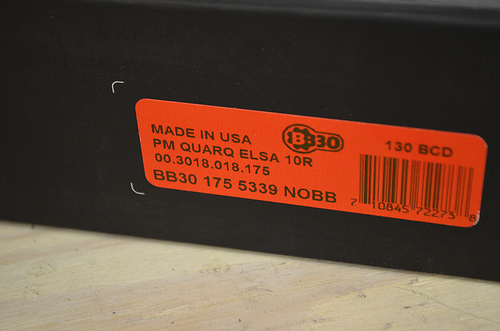<image>
Can you confirm if the label is under the modem? No. The label is not positioned under the modem. The vertical relationship between these objects is different. 